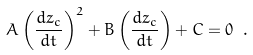Convert formula to latex. <formula><loc_0><loc_0><loc_500><loc_500>A \left ( \frac { d z _ { c } } { d t } \right ) ^ { 2 } + B \left ( \frac { d z _ { c } } { d t } \right ) + C = 0 \ .</formula> 